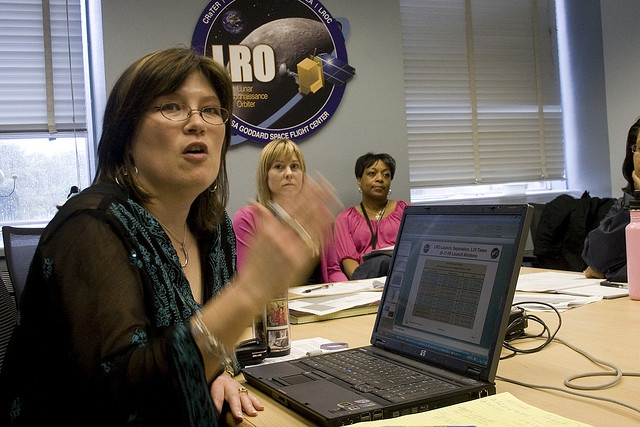Describe the objects in this image and their specific colors. I can see people in darkgray, black, gray, maroon, and tan tones, laptop in darkgray, black, and gray tones, people in darkgray, brown, black, and maroon tones, people in darkgray, brown, olive, tan, and maroon tones, and people in darkgray, black, gray, and olive tones in this image. 